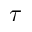<formula> <loc_0><loc_0><loc_500><loc_500>\tau</formula> 